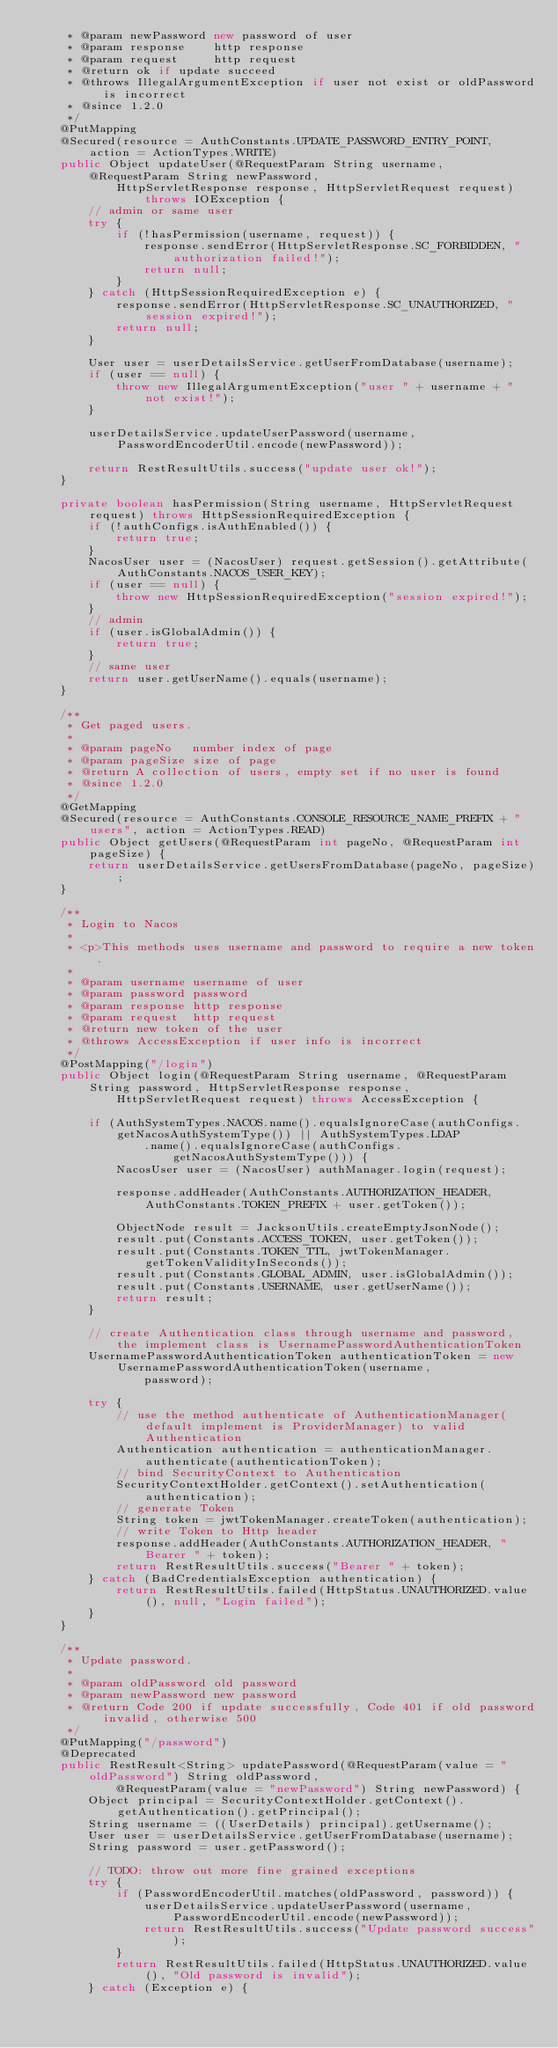Convert code to text. <code><loc_0><loc_0><loc_500><loc_500><_Java_>     * @param newPassword new password of user
     * @param response    http response
     * @param request     http request
     * @return ok if update succeed
     * @throws IllegalArgumentException if user not exist or oldPassword is incorrect
     * @since 1.2.0
     */
    @PutMapping
    @Secured(resource = AuthConstants.UPDATE_PASSWORD_ENTRY_POINT, action = ActionTypes.WRITE)
    public Object updateUser(@RequestParam String username, @RequestParam String newPassword,
            HttpServletResponse response, HttpServletRequest request) throws IOException {
        // admin or same user
        try {
            if (!hasPermission(username, request)) {
                response.sendError(HttpServletResponse.SC_FORBIDDEN, "authorization failed!");
                return null;
            }
        } catch (HttpSessionRequiredException e) {
            response.sendError(HttpServletResponse.SC_UNAUTHORIZED, "session expired!");
            return null;
        }
    
        User user = userDetailsService.getUserFromDatabase(username);
        if (user == null) {
            throw new IllegalArgumentException("user " + username + " not exist!");
        }
        
        userDetailsService.updateUserPassword(username, PasswordEncoderUtil.encode(newPassword));
        
        return RestResultUtils.success("update user ok!");
    }
    
    private boolean hasPermission(String username, HttpServletRequest request) throws HttpSessionRequiredException {
        if (!authConfigs.isAuthEnabled()) {
            return true;
        }
        NacosUser user = (NacosUser) request.getSession().getAttribute(AuthConstants.NACOS_USER_KEY);
        if (user == null) {
            throw new HttpSessionRequiredException("session expired!");
        }
        // admin
        if (user.isGlobalAdmin()) {
            return true;
        }
        // same user
        return user.getUserName().equals(username);
    }
    
    /**
     * Get paged users.
     *
     * @param pageNo   number index of page
     * @param pageSize size of page
     * @return A collection of users, empty set if no user is found
     * @since 1.2.0
     */
    @GetMapping
    @Secured(resource = AuthConstants.CONSOLE_RESOURCE_NAME_PREFIX + "users", action = ActionTypes.READ)
    public Object getUsers(@RequestParam int pageNo, @RequestParam int pageSize) {
        return userDetailsService.getUsersFromDatabase(pageNo, pageSize);
    }
    
    /**
     * Login to Nacos
     *
     * <p>This methods uses username and password to require a new token.
     *
     * @param username username of user
     * @param password password
     * @param response http response
     * @param request  http request
     * @return new token of the user
     * @throws AccessException if user info is incorrect
     */
    @PostMapping("/login")
    public Object login(@RequestParam String username, @RequestParam String password, HttpServletResponse response,
            HttpServletRequest request) throws AccessException {
        
        if (AuthSystemTypes.NACOS.name().equalsIgnoreCase(authConfigs.getNacosAuthSystemType()) || AuthSystemTypes.LDAP
                .name().equalsIgnoreCase(authConfigs.getNacosAuthSystemType())) {
            NacosUser user = (NacosUser) authManager.login(request);
            
            response.addHeader(AuthConstants.AUTHORIZATION_HEADER, AuthConstants.TOKEN_PREFIX + user.getToken());
            
            ObjectNode result = JacksonUtils.createEmptyJsonNode();
            result.put(Constants.ACCESS_TOKEN, user.getToken());
            result.put(Constants.TOKEN_TTL, jwtTokenManager.getTokenValidityInSeconds());
            result.put(Constants.GLOBAL_ADMIN, user.isGlobalAdmin());
            result.put(Constants.USERNAME, user.getUserName());
            return result;
        }
        
        // create Authentication class through username and password, the implement class is UsernamePasswordAuthenticationToken
        UsernamePasswordAuthenticationToken authenticationToken = new UsernamePasswordAuthenticationToken(username,
                password);
        
        try {
            // use the method authenticate of AuthenticationManager(default implement is ProviderManager) to valid Authentication
            Authentication authentication = authenticationManager.authenticate(authenticationToken);
            // bind SecurityContext to Authentication
            SecurityContextHolder.getContext().setAuthentication(authentication);
            // generate Token
            String token = jwtTokenManager.createToken(authentication);
            // write Token to Http header
            response.addHeader(AuthConstants.AUTHORIZATION_HEADER, "Bearer " + token);
            return RestResultUtils.success("Bearer " + token);
        } catch (BadCredentialsException authentication) {
            return RestResultUtils.failed(HttpStatus.UNAUTHORIZED.value(), null, "Login failed");
        }
    }
    
    /**
     * Update password.
     *
     * @param oldPassword old password
     * @param newPassword new password
     * @return Code 200 if update successfully, Code 401 if old password invalid, otherwise 500
     */
    @PutMapping("/password")
    @Deprecated
    public RestResult<String> updatePassword(@RequestParam(value = "oldPassword") String oldPassword,
            @RequestParam(value = "newPassword") String newPassword) {
        Object principal = SecurityContextHolder.getContext().getAuthentication().getPrincipal();
        String username = ((UserDetails) principal).getUsername();
        User user = userDetailsService.getUserFromDatabase(username);
        String password = user.getPassword();
        
        // TODO: throw out more fine grained exceptions
        try {
            if (PasswordEncoderUtil.matches(oldPassword, password)) {
                userDetailsService.updateUserPassword(username, PasswordEncoderUtil.encode(newPassword));
                return RestResultUtils.success("Update password success");
            }
            return RestResultUtils.failed(HttpStatus.UNAUTHORIZED.value(), "Old password is invalid");
        } catch (Exception e) {</code> 